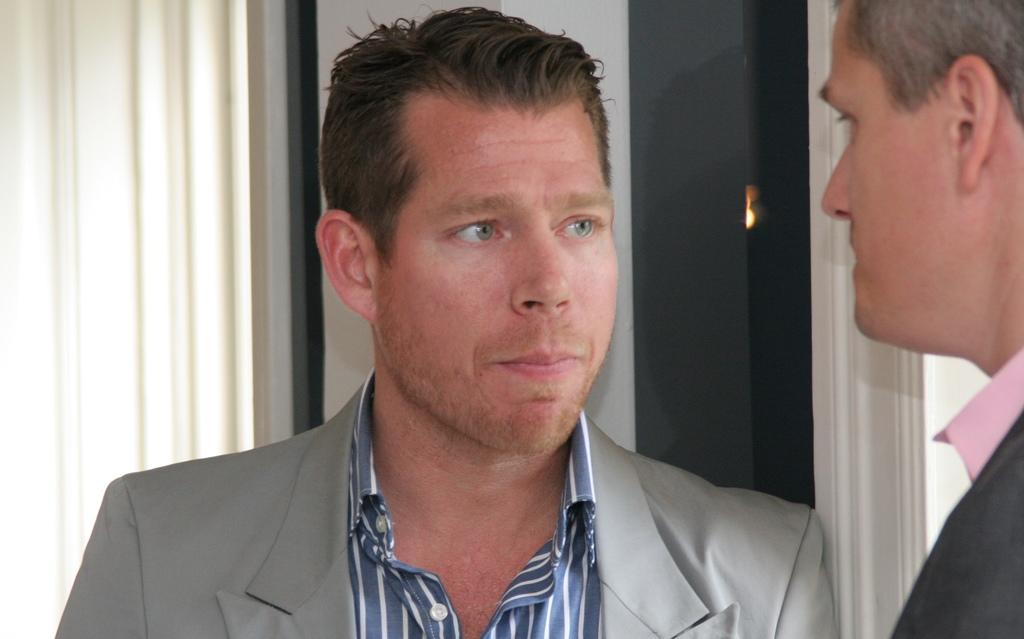How many people are present in the image? There are two men in the image. What are the men doing in the image? The men are standing. What are the men wearing in the image? The men are wearing blazers. What can be seen in the background of the image? There is a window in the background of the image. Is there any window treatment present in the image? Yes, there is a curtain associated with the window. What types of toys can be seen on the floor in the image? There are no toys present in the image; it features two men standing and wearing blazers. 